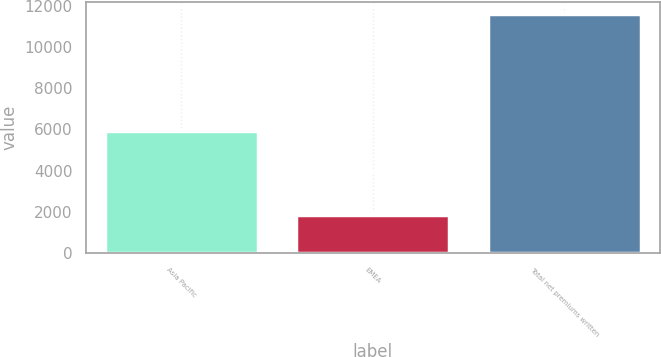<chart> <loc_0><loc_0><loc_500><loc_500><bar_chart><fcel>Asia Pacific<fcel>EMEA<fcel>Total net premiums written<nl><fcel>5916<fcel>1854<fcel>11580<nl></chart> 